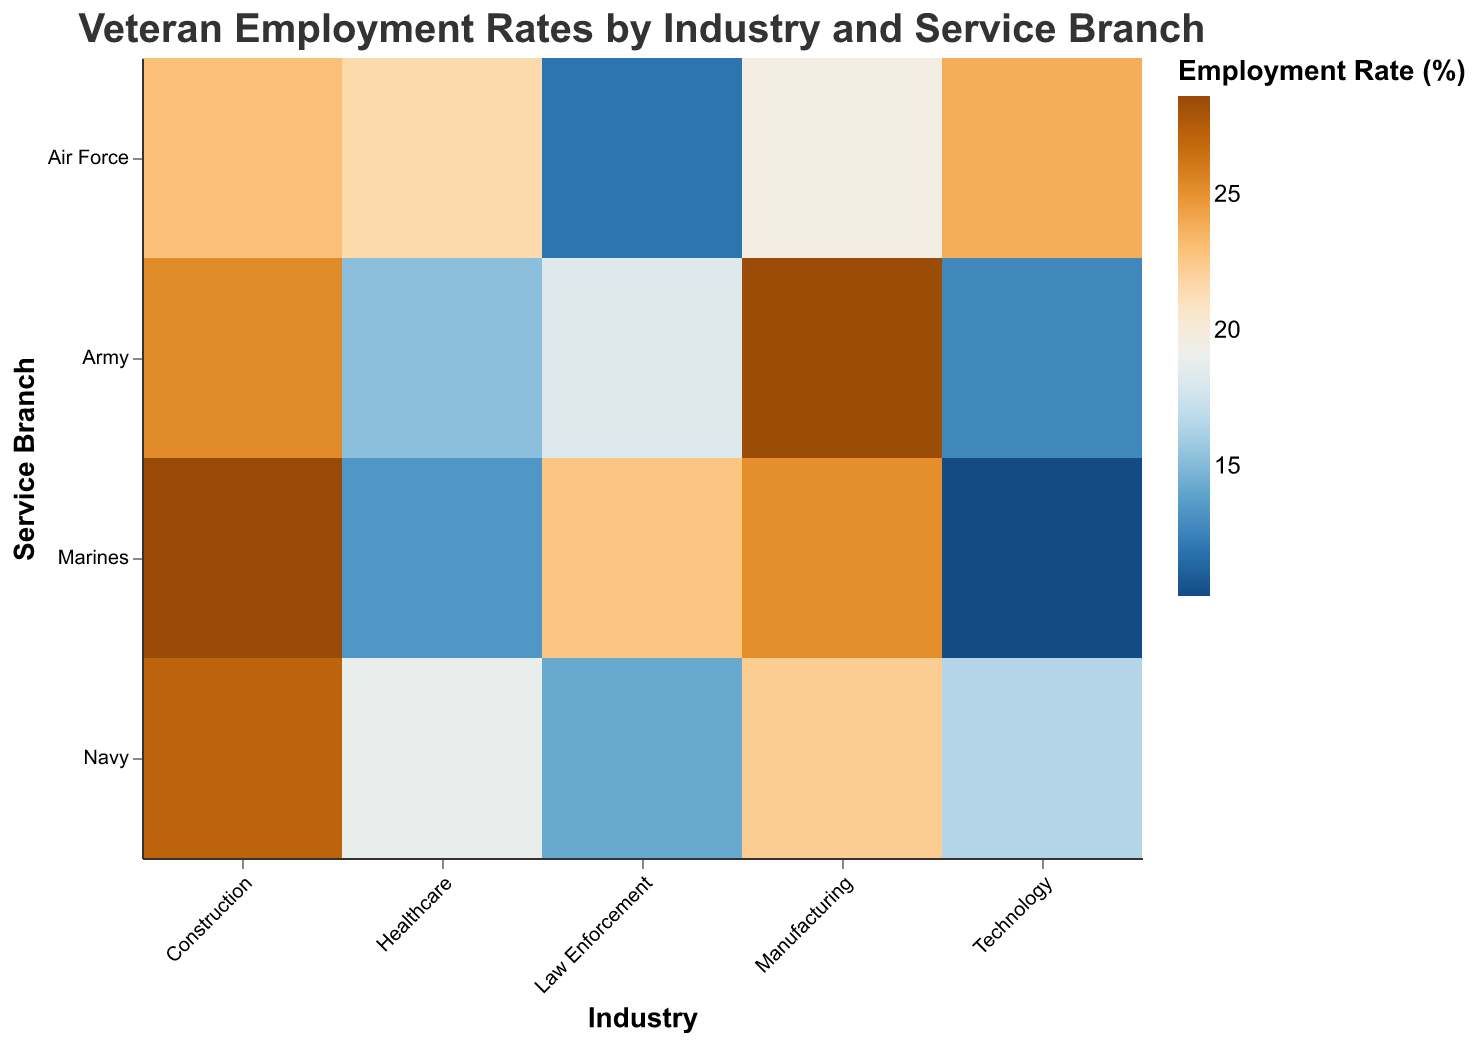What's the title of the figure? The title of the figure is the main text displayed at the top, giving an overview of what the figure represents. The title of this figure is "Veteran Employment Rates by Industry and Service Branch".
Answer: Veteran Employment Rates by Industry and Service Branch How many different industries are shown in the figure? To determine the number of different industries, observe the x-axis labels, which list all the industries. The industries are Manufacturing, Healthcare, Technology, Law Enforcement, and Construction.
Answer: 5 Which service branch has the highest employment rate in Manufacturing? To find this, look at the Manufacturing column and identify the highest color intensity indicating a higher employment rate. The "Marines" row within the Manufacturing column has the highest intensity.
Answer: Marines Which industry has the lowest employment rate for the Marines? Examine the rows corresponding to the Marines across all industries. The Technology column has the lowest color intensity for the Marines.
Answer: Technology Compare the employment rates of the Air Force in Technology and Healthcare. Which one is higher? Look at the Air Force row and compare the color intensities in the Technology and Healthcare columns. The Technology column has a higher color intensity for the Air Force.
Answer: Technology What is the difference in employment rates between the Army in Construction and the Marines in Manufacturing? Observe the respective cells and note the employment rates: Army in Construction is 25.3% and Marines in Manufacturing is 25.1%. Calculate the difference, which is 25.3 - 25.1.
Answer: 0.2% Which service branch has the most consistent employment rates across all industries? Scan the rows for each service branch and observe the variations in color intensity. "Army" seems to have the most evenly distributed colors across all industries, indicating consistency.
Answer: Army What are the average employment rates of the Navy across all industries? Identify the rates for Navy in each industry: Manufacturing (22.3), Healthcare (18.9), Technology (16.5), Law Enforcement (14.2), and Construction (27.1). Calculate the average: (22.3 + 18.9 + 16.5 + 14.2 + 27.1) / 5.
Answer: 19.8 In which industry is the employment rate for the Navy greater than both the Army and Air Force? Compare the Navy employment rates with the Army and Air Force across all industries. In the Construction industry, the Navy (27.1) has a higher employment rate than both the Army (25.3) and Air Force (23.0).
Answer: Construction Which industry shows the largest discrepancy in employment rates among different service branches? Observe the columns for each industry and identify the one with the widest range of colors, indicating the largest discrepancy. The "Technology" industry shows the largest variation in color intensity.
Answer: Technology 